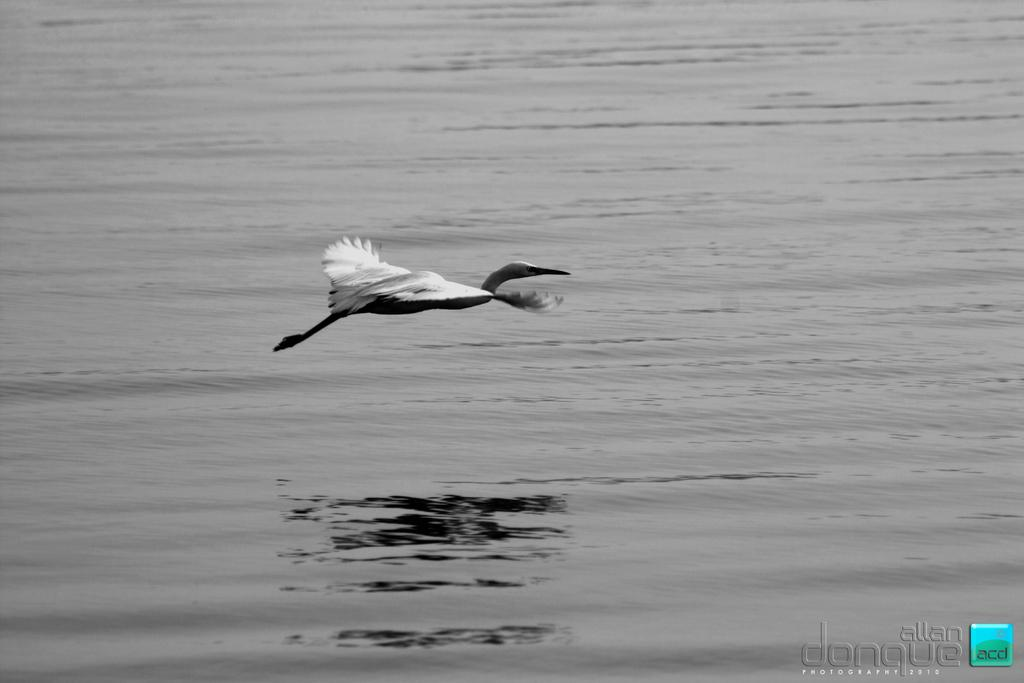What is the primary element in the image? There is water in the image. What type of animal can be seen in the image? There is a bird in the image. What is the bird doing in the image? The bird is flying in the air. Is there any text or marking in the image? Yes, there is a watermark in the bottom right side of the image. What type of soda is the bird drinking in the image? There is no soda present in the image; it features a bird flying over water. What is the bird's limit for flying in the image? The image does not specify a limit for the bird's flying; it is simply flying in the air. 